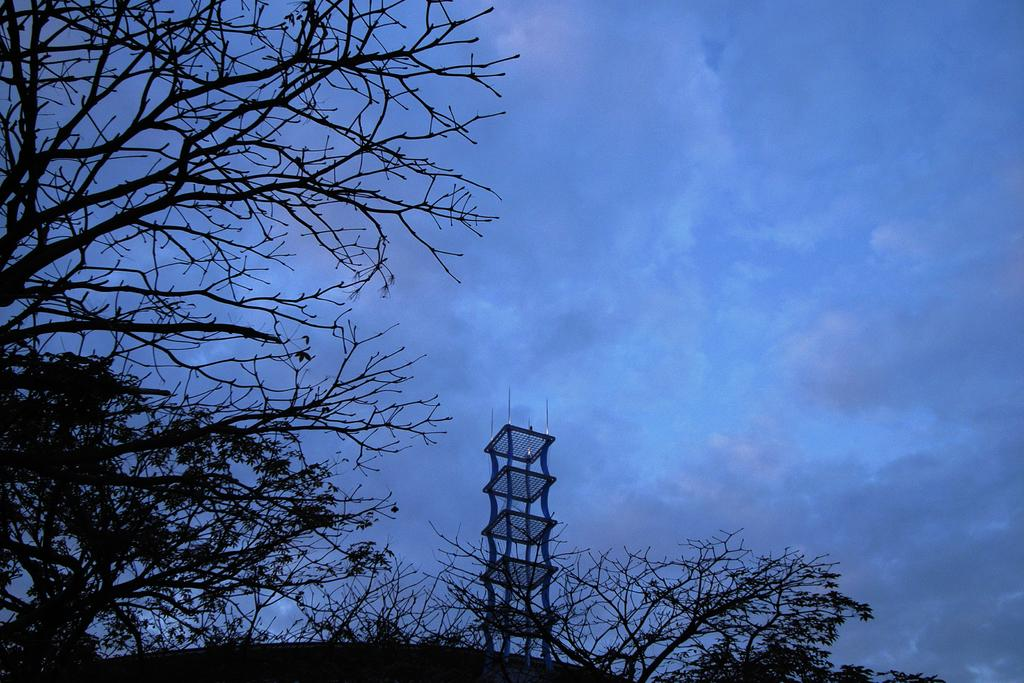What type of trees can be seen on the left side of the image? There are deciduous trees on the left side of the image. What is happening at the bottom of the image? There is a tower construction at the bottom of the image. What can be seen in the sky in the image? There are clouds in the sky. What type of harmony is being played by the trees in the image? There is no indication of harmony being played by the trees in the image, as trees do not produce music. Can you describe the haircut of the clouds in the image? There is no haircut associated with the clouds in the image, as clouds are not living beings with hair. 